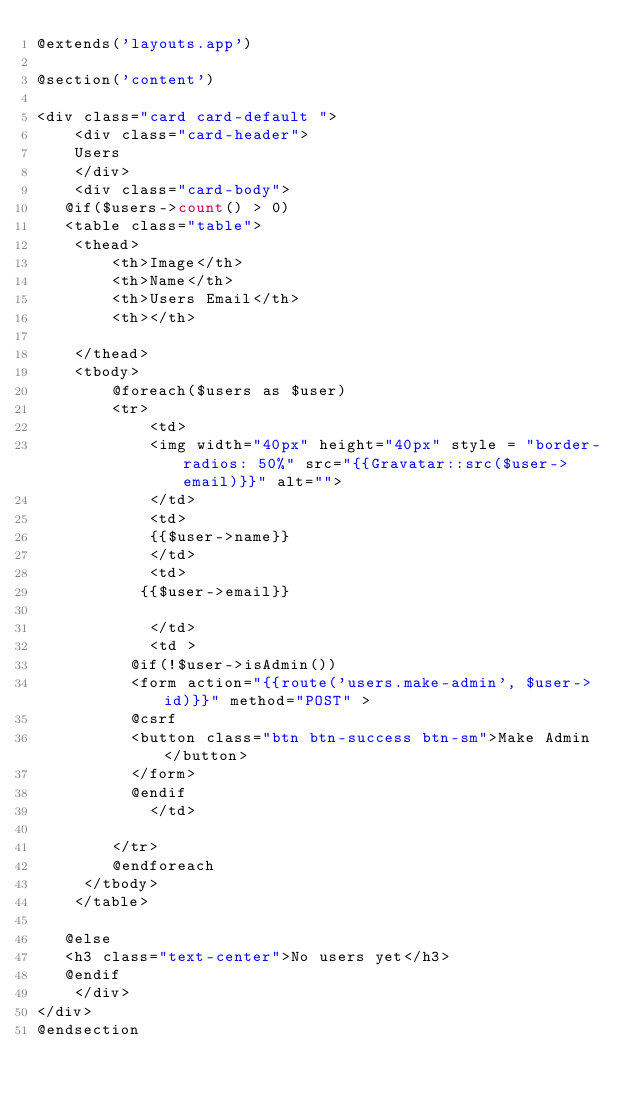Convert code to text. <code><loc_0><loc_0><loc_500><loc_500><_PHP_>@extends('layouts.app')

@section('content')

<div class="card card-default ">
    <div class="card-header">
    Users
    </div>
    <div class="card-body">
   @if($users->count() > 0)
   <table class="table">
    <thead>
        <th>Image</th>
        <th>Name</th>
        <th>Users Email</th>
        <th></th>
       
    </thead>
    <tbody>
        @foreach($users as $user)
        <tr>
            <td>
            <img width="40px" height="40px" style = "border-radios: 50%" src="{{Gravatar::src($user->email)}}" alt="">
            </td>
            <td>
            {{$user->name}}
            </td>
            <td>
           {{$user->email}}
          
            </td>
            <td >
          @if(!$user->isAdmin())
          <form action="{{route('users.make-admin', $user->id)}}" method="POST" >
          @csrf
          <button class="btn btn-success btn-sm">Make Admin</button>
          </form>
          @endif
            </td>
            
        </tr>
        @endforeach
     </tbody>
    </table>

   @else
   <h3 class="text-center">No users yet</h3>
   @endif
    </div>
</div>
@endsection</code> 